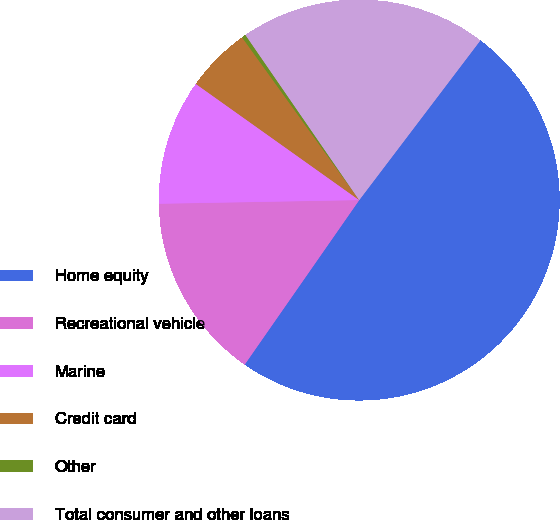Convert chart to OTSL. <chart><loc_0><loc_0><loc_500><loc_500><pie_chart><fcel>Home equity<fcel>Recreational vehicle<fcel>Marine<fcel>Credit card<fcel>Other<fcel>Total consumer and other loans<nl><fcel>49.35%<fcel>15.03%<fcel>10.13%<fcel>5.23%<fcel>0.33%<fcel>19.93%<nl></chart> 